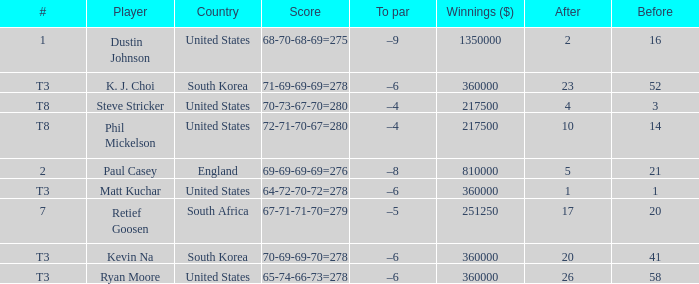What is the player listed when the score is 68-70-68-69=275 Dustin Johnson. 